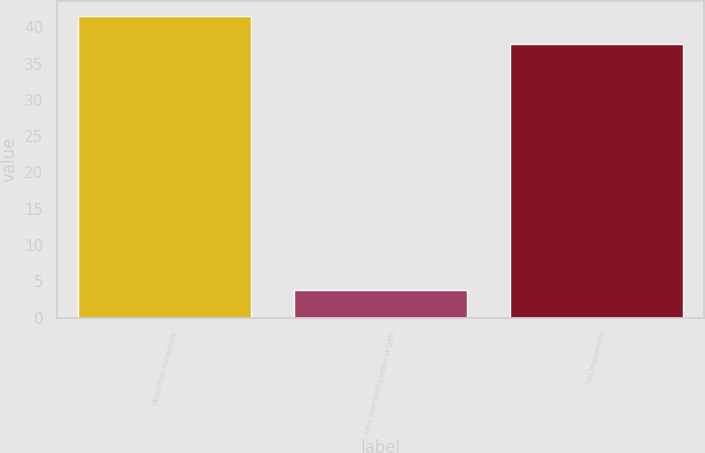Convert chart to OTSL. <chart><loc_0><loc_0><loc_500><loc_500><bar_chart><fcel>Other-than-temporary<fcel>Less noncredit portion of OTTI<fcel>Net impairment<nl><fcel>41.5<fcel>3.8<fcel>37.7<nl></chart> 